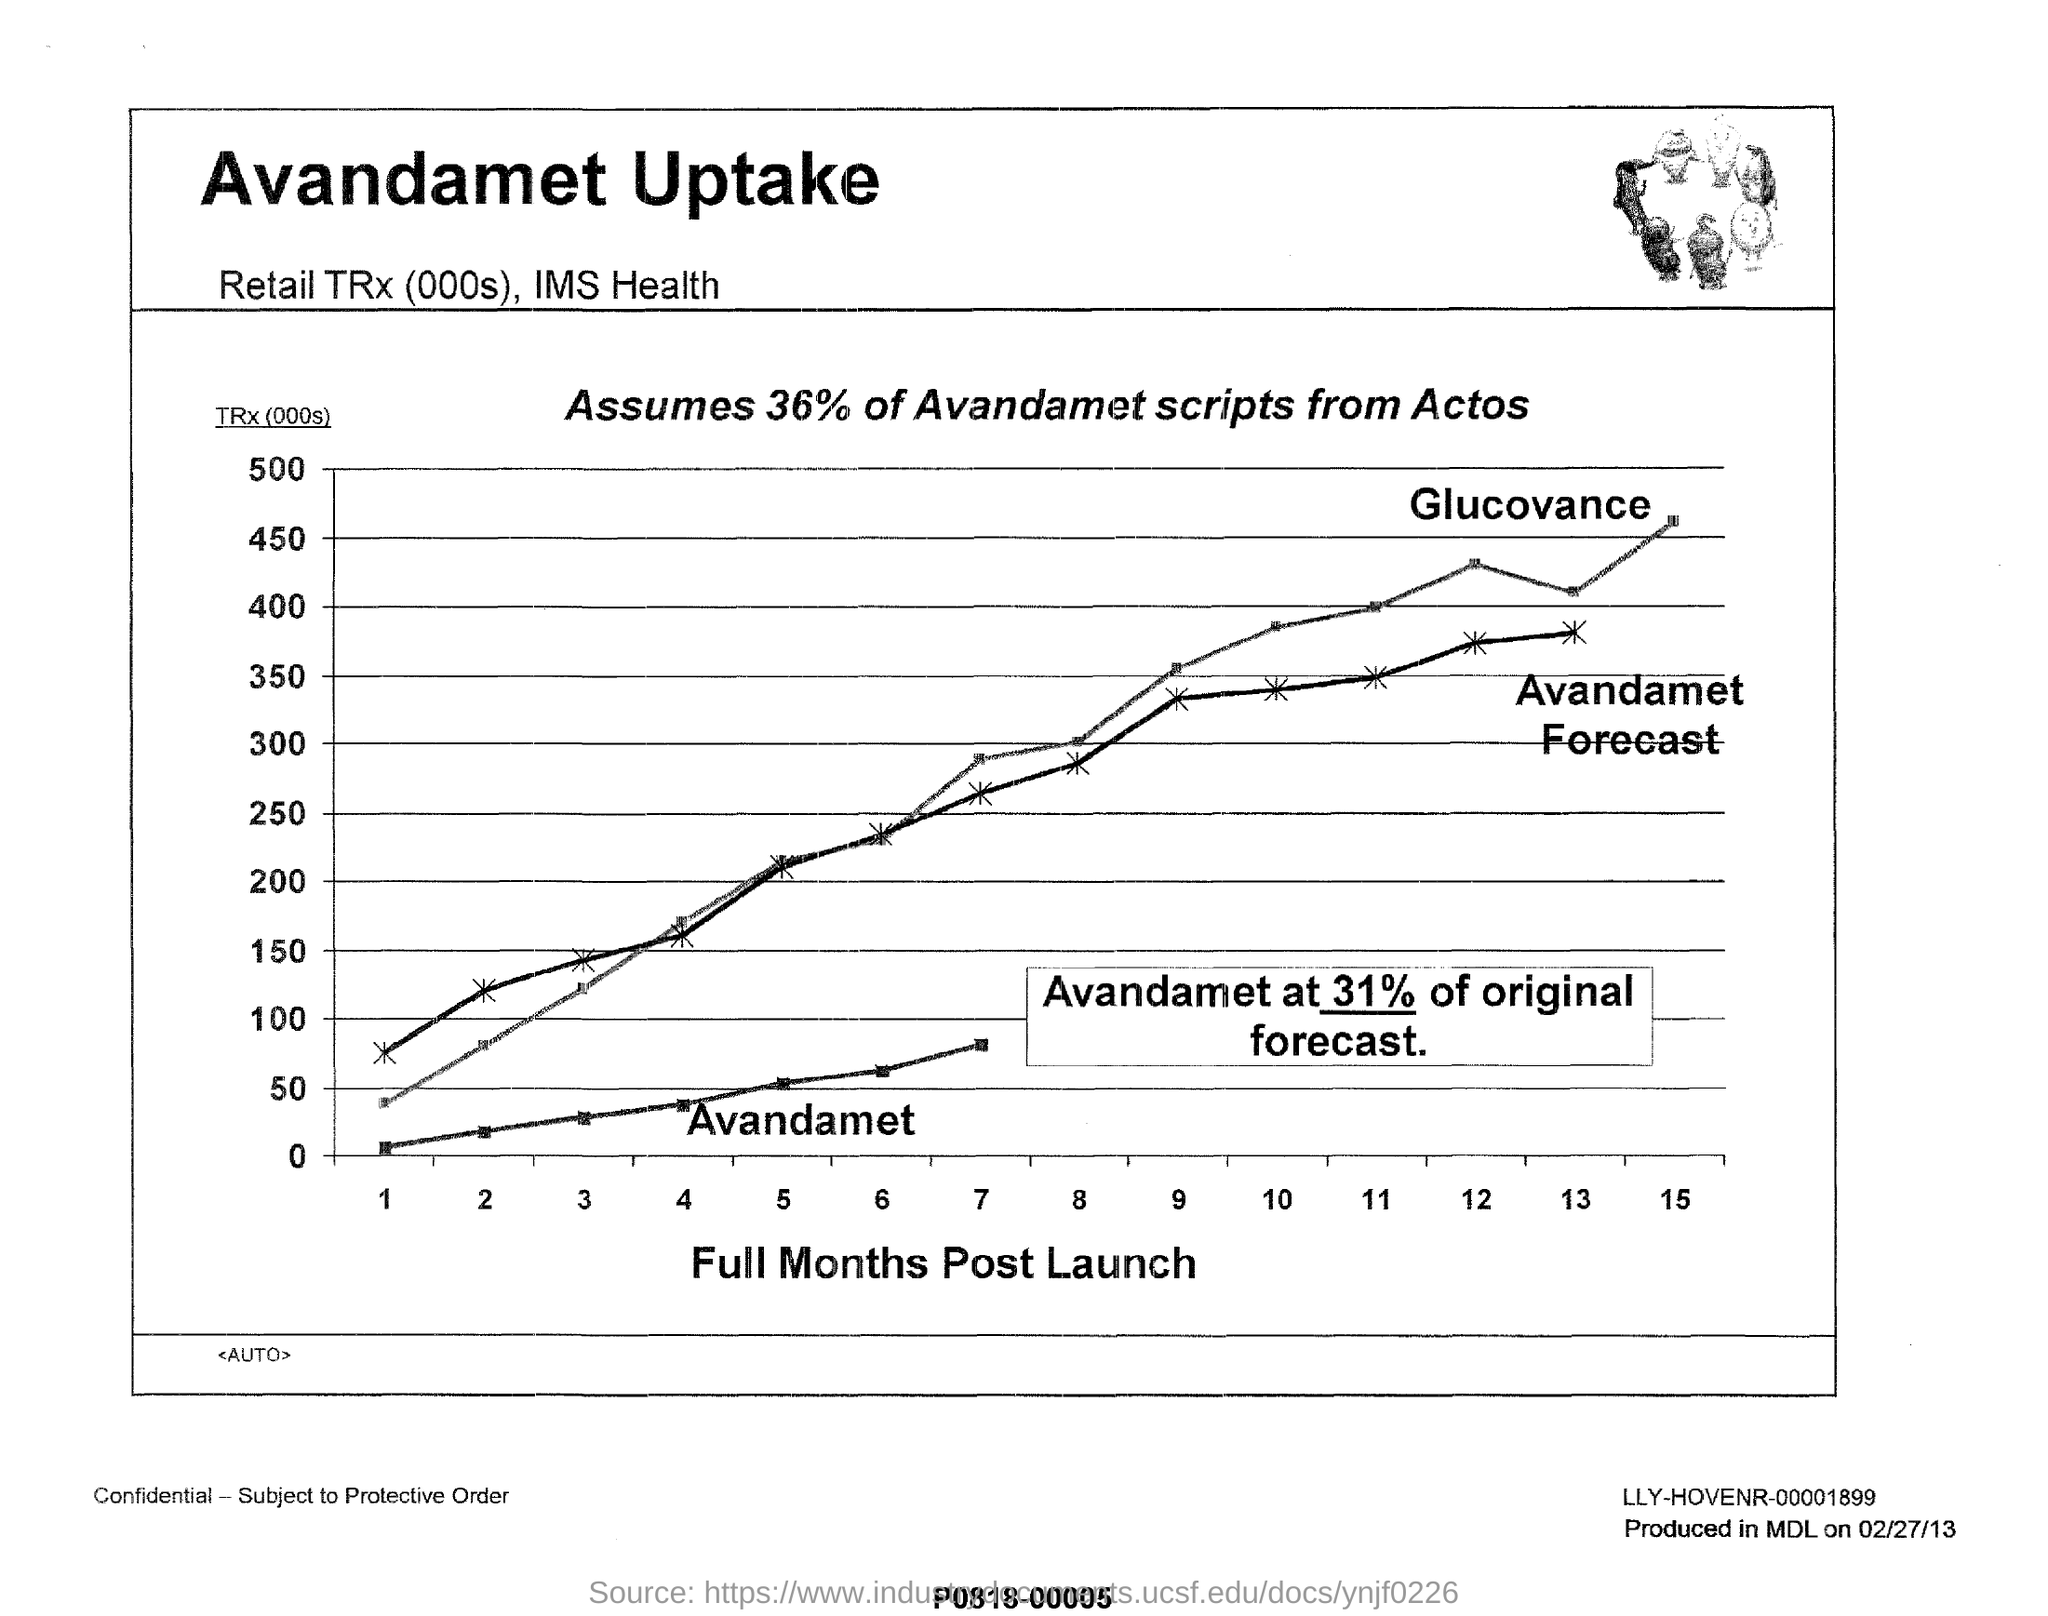Indicate a few pertinent items in this graphic. What is on the horizontal axis of the graph? Full months post-launch. The x-axis displays the full months post-launch, providing a clear and concise representation of the timeline. Avandamet scripts from Actos were mentioned in 36% of cases. The document heading is "Avandamet Uptake". 